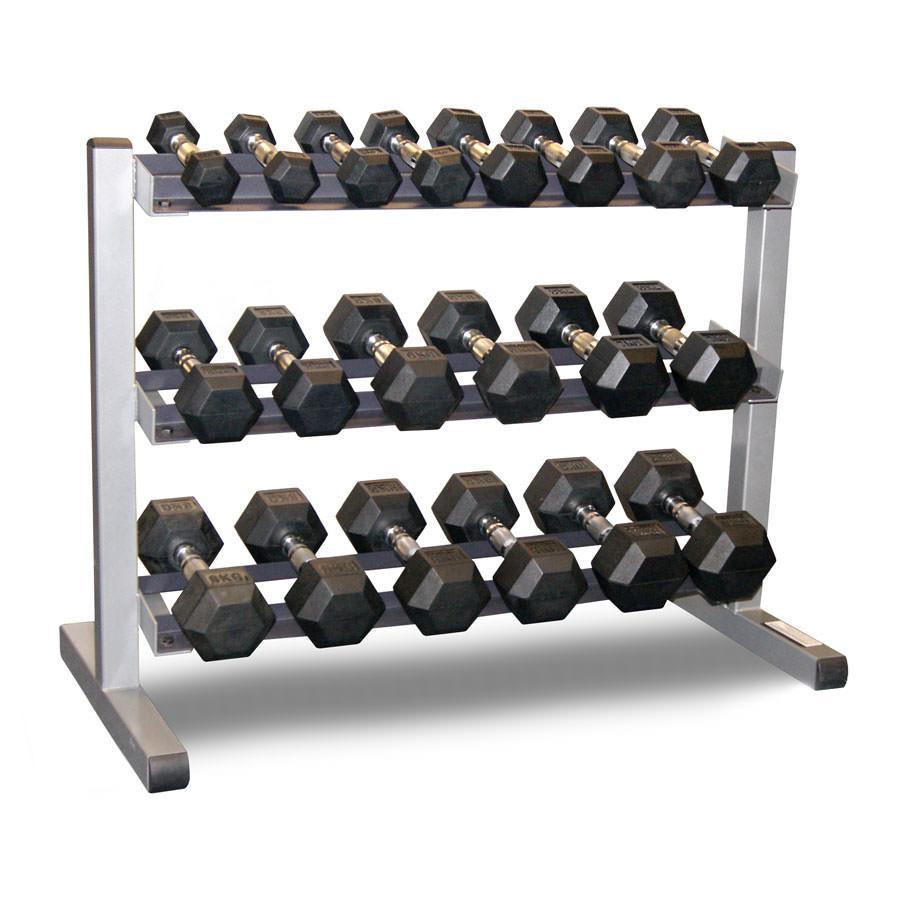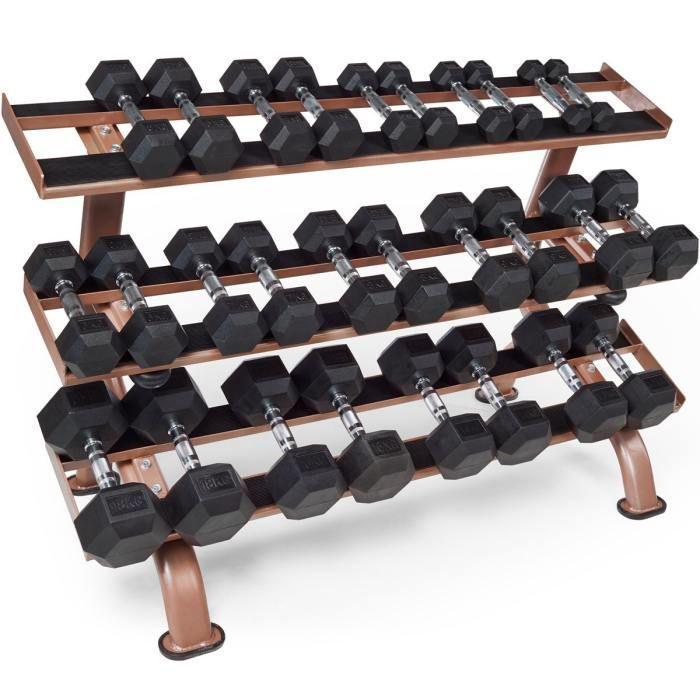The first image is the image on the left, the second image is the image on the right. Examine the images to the left and right. Is the description "Right image shows a weight rack with exactly two horizontal rows of dumbbells." accurate? Answer yes or no. No. The first image is the image on the left, the second image is the image on the right. Given the left and right images, does the statement "A white rack with three layers is in the left image." hold true? Answer yes or no. Yes. 